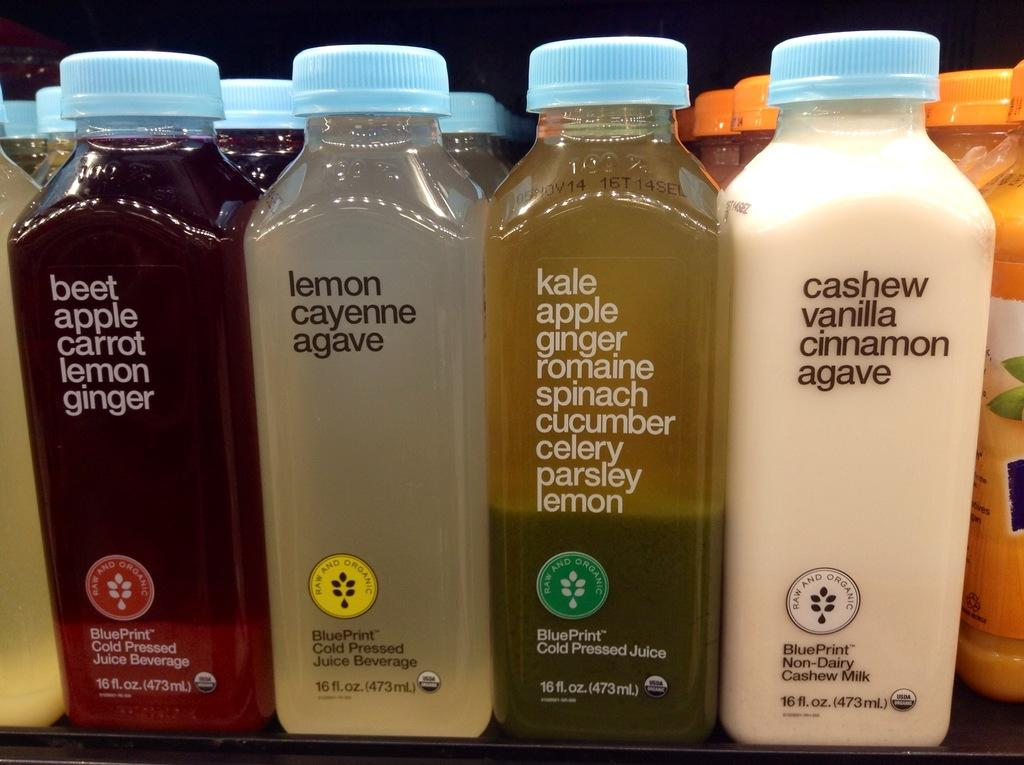<image>
Provide a brief description of the given image. bottle of liquid next to one another with one of them called 'lemon cayenne agave' 